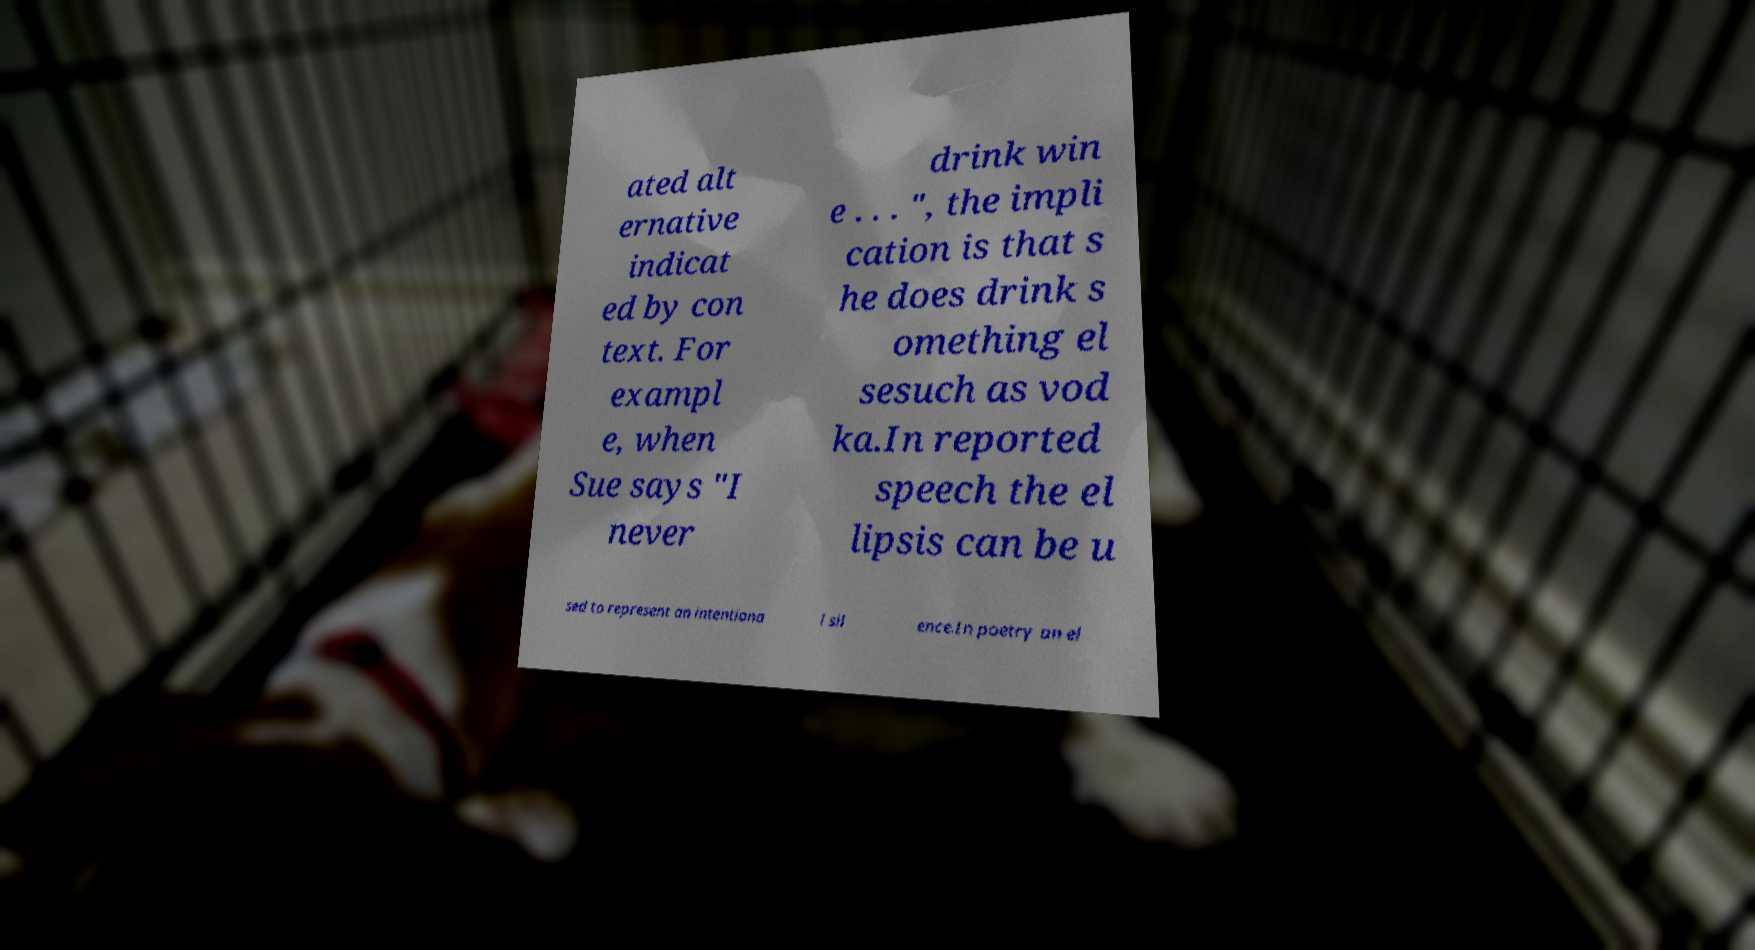What messages or text are displayed in this image? I need them in a readable, typed format. ated alt ernative indicat ed by con text. For exampl e, when Sue says "I never drink win e . . . ", the impli cation is that s he does drink s omething el sesuch as vod ka.In reported speech the el lipsis can be u sed to represent an intentiona l sil ence.In poetry an el 